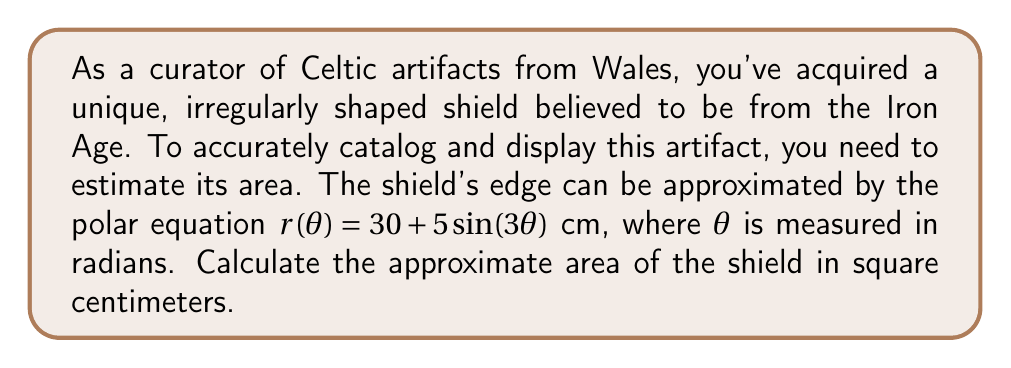Can you solve this math problem? To estimate the area of the irregularly shaped Celtic shield using a polar coordinate system, we'll follow these steps:

1) The area of a region in polar coordinates is given by the formula:

   $$A = \frac{1}{2} \int_{0}^{2\pi} [r(\theta)]^2 d\theta$$

2) In this case, $r(\theta) = 30 + 5\sin(3\theta)$ cm. We need to square this function:

   $$[r(\theta)]^2 = (30 + 5\sin(3\theta))^2 = 900 + 300\sin(3\theta) + 25\sin^2(3\theta)$$

3) Now, we substitute this into our integral:

   $$A = \frac{1}{2} \int_{0}^{2\pi} (900 + 300\sin(3\theta) + 25\sin^2(3\theta)) d\theta$$

4) Let's evaluate each term separately:

   a) $\int_{0}^{2\pi} 900 d\theta = 900 \cdot 2\pi = 1800\pi$

   b) $\int_{0}^{2\pi} 300\sin(3\theta) d\theta = -100\cos(3\theta)|_{0}^{2\pi} = 0$

   c) $\int_{0}^{2\pi} 25\sin^2(3\theta) d\theta = 25 \cdot \frac{\pi}{2} = \frac{25\pi}{2}$

5) Adding these results:

   $$A = \frac{1}{2} (1800\pi + 0 + \frac{25\pi}{2}) = 900\pi + \frac{25\pi}{4} = \frac{3625\pi}{4}$$

6) Therefore, the area of the shield is approximately:

   $$A = \frac{3625\pi}{4} \approx 2846.15 \text{ cm}^2$$
Answer: The approximate area of the Celtic shield is 2846.15 square centimeters. 